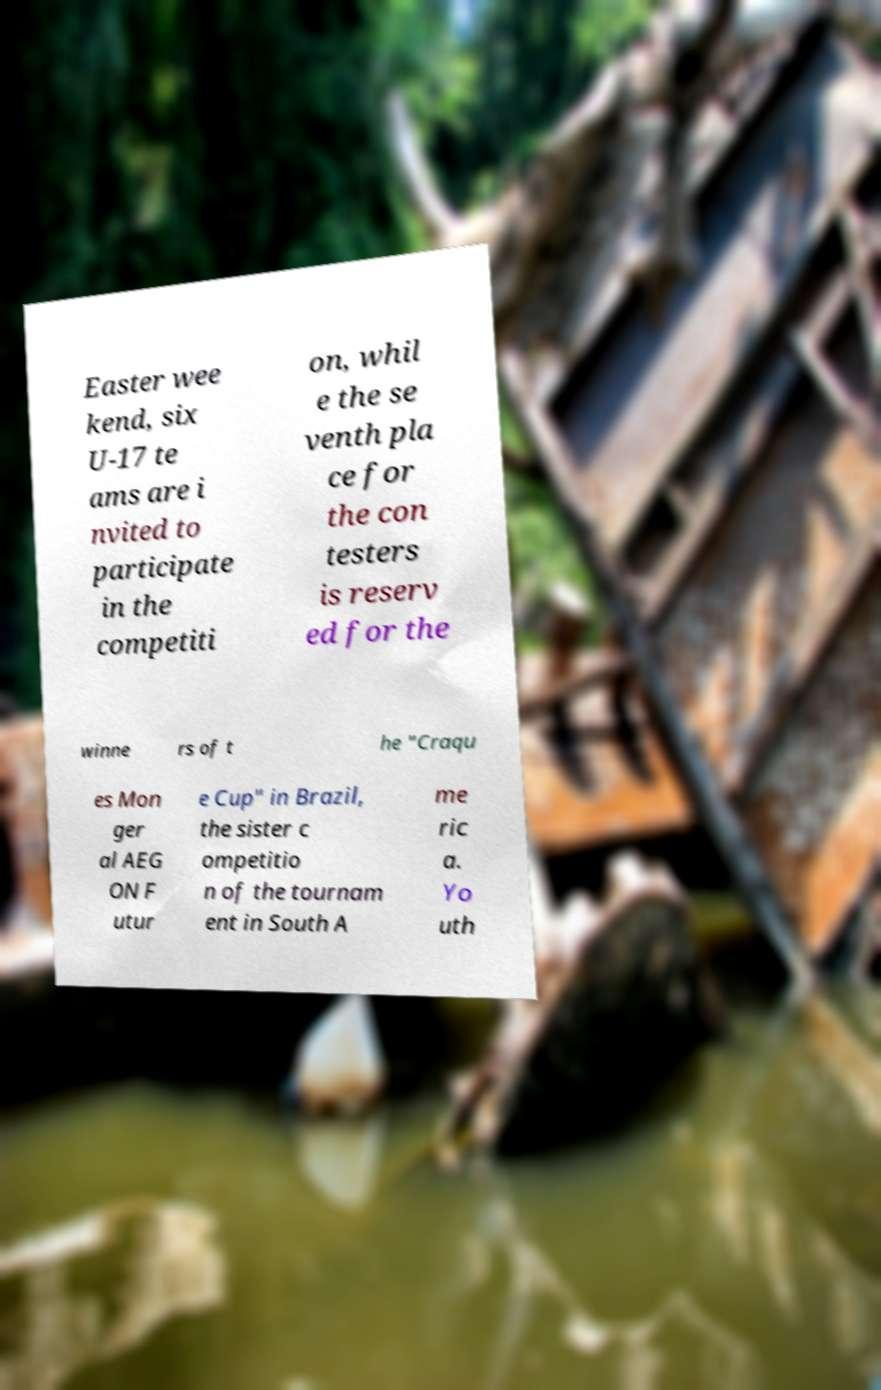I need the written content from this picture converted into text. Can you do that? Easter wee kend, six U-17 te ams are i nvited to participate in the competiti on, whil e the se venth pla ce for the con testers is reserv ed for the winne rs of t he "Craqu es Mon ger al AEG ON F utur e Cup" in Brazil, the sister c ompetitio n of the tournam ent in South A me ric a. Yo uth 